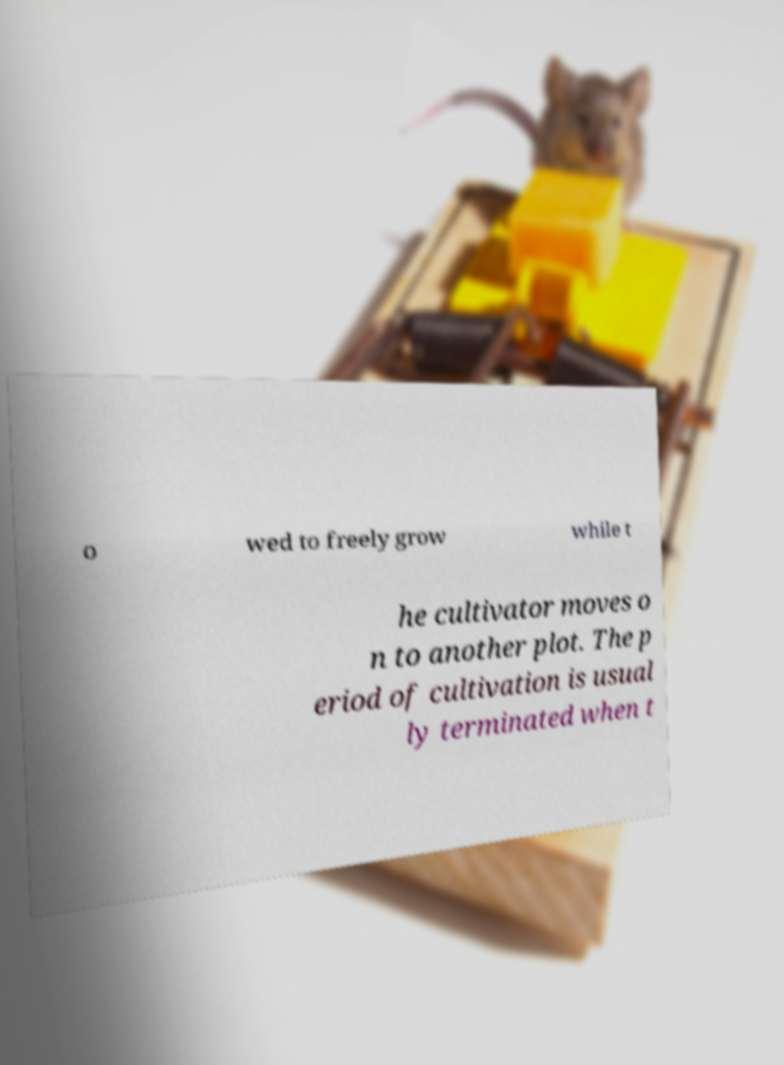There's text embedded in this image that I need extracted. Can you transcribe it verbatim? o wed to freely grow while t he cultivator moves o n to another plot. The p eriod of cultivation is usual ly terminated when t 